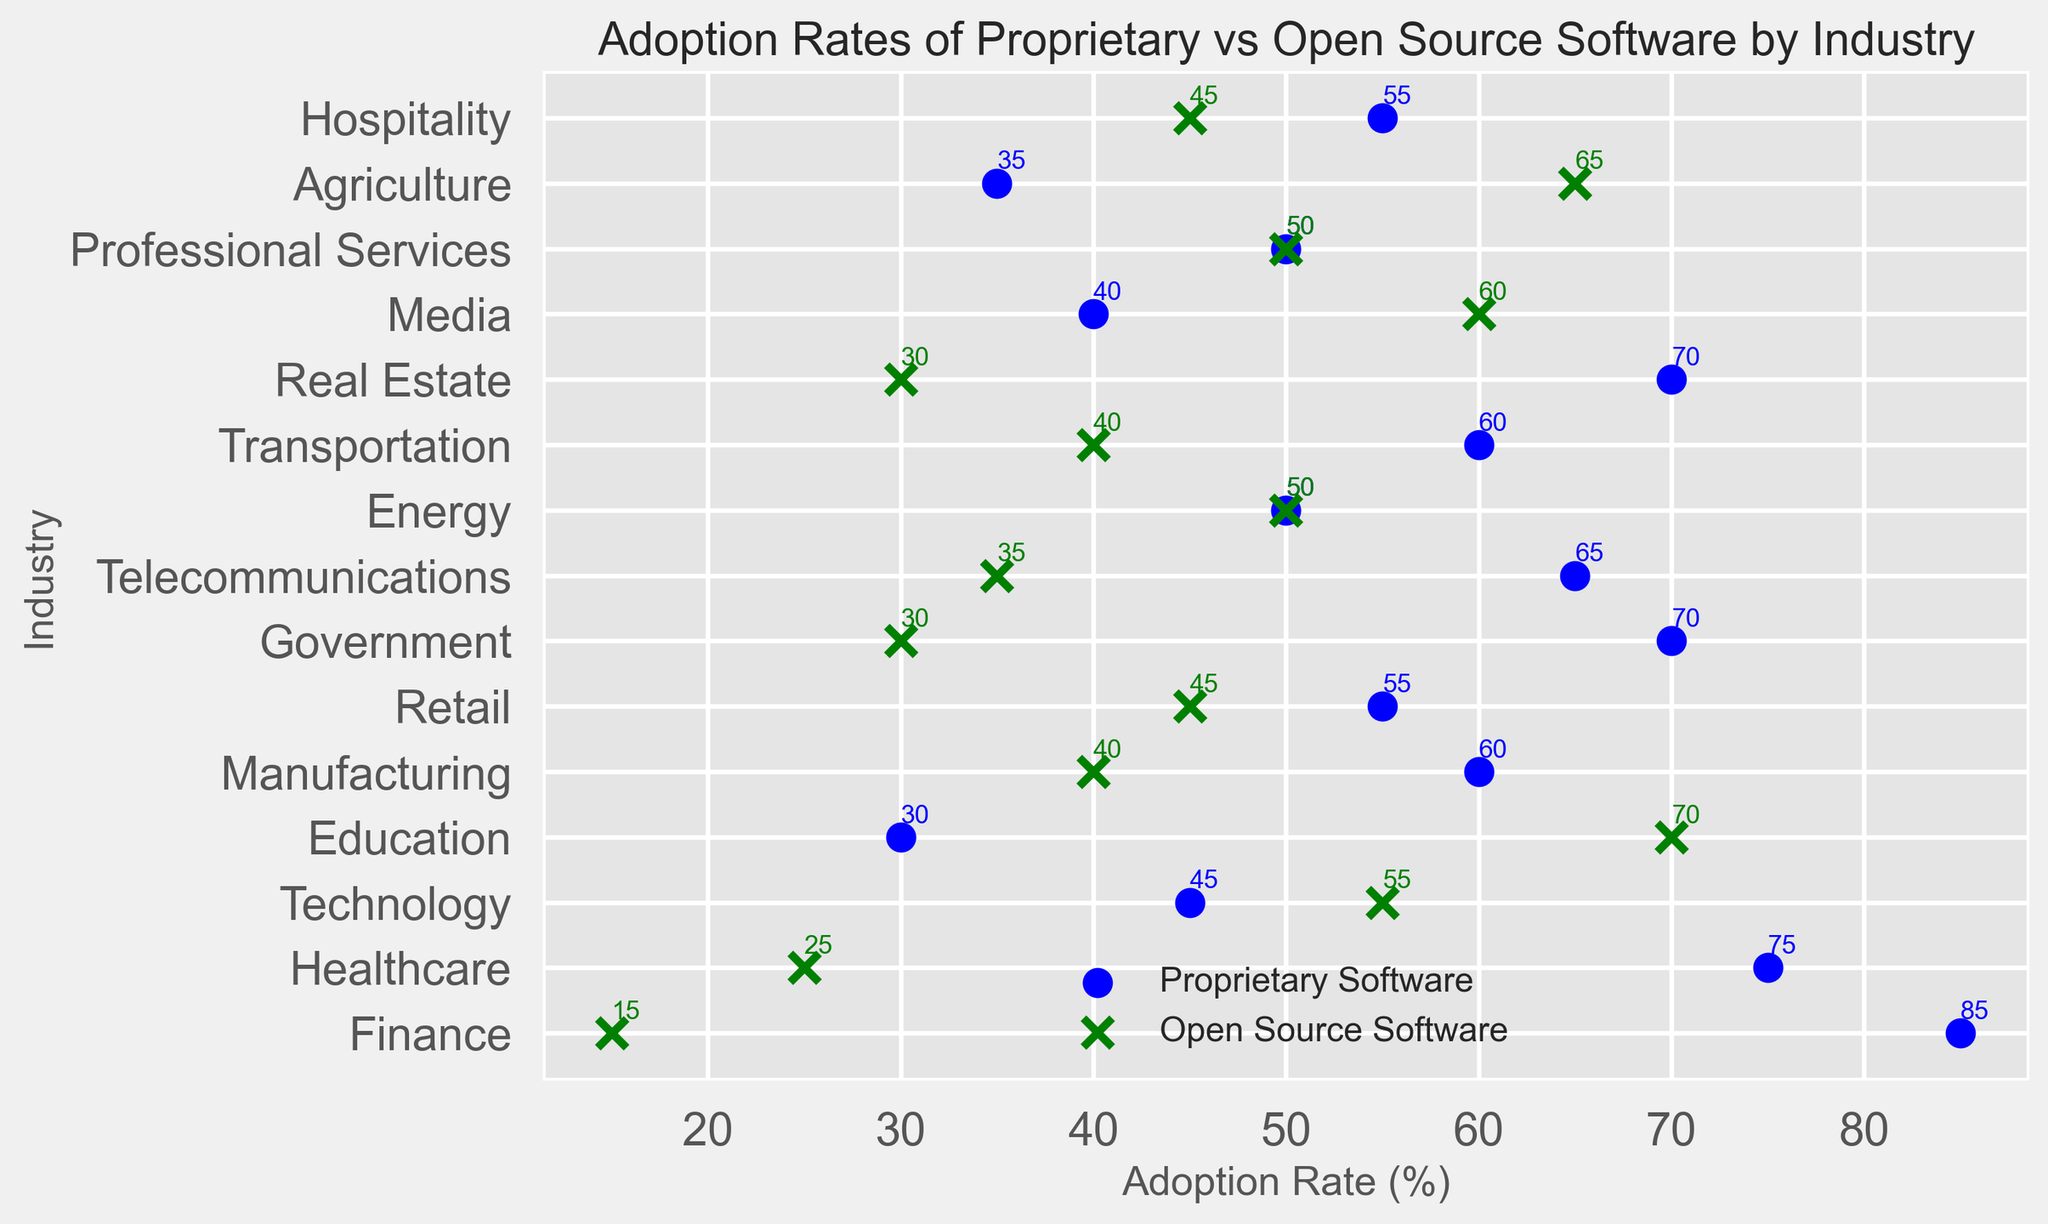What industry has the highest adoption rate for proprietary software? To find this, locate the marker on the scatter plot where the adoption rate for proprietary software is highest. The industry with the highest adoption rate for proprietary software is Finance with 85%.
Answer: Finance Which industry has a higher adoption rate for open source software: Technology or Healthcare? Compare the open source software adoption rates for Technology and Healthcare. Technology has an adoption rate of 55%, while Healthcare has a lower adoption rate of 25%. Thus, Technology has a higher adoption rate for open source software.
Answer: Technology Which industry shows equal adoption rates for both proprietary and open source software? Identify any markers where the adoption rates for proprietary and open source software are the same. Both Energy and Professional Services show equal adoption rates of 50% for both types of software.
Answer: Energy and Professional Services What is the difference in open source software adoption rates between Agriculture and Media? Subtract the open source software adoption rate of Agriculture from that of Media (65% - 60%). The difference is 5%.
Answer: 5% For Telecommunications, how much higher is the adoption rate for proprietary software compared to open source software? Subtract the open source software adoption rate from the proprietary software adoption rate for Telecommunications (65% - 35%). The difference is 30%.
Answer: 30% Which industry has a lower proprietary software adoption rate: Retail or Manufacturing? Compare the proprietary software adoption rates for Retail and Manufacturing. Retail has an adoption rate of 55%, while Manufacturing has a higher rate of 60%. Thus, Retail has a lower adoption rate.
Answer: Retail How does the adoption rate of open source software in Education compare to that in Hospitality? Compare the open source software adoption rates for Education and Hospitality. Education has a higher adoption rate of 70% compared to 45% for Hospitality.
Answer: Higher What is the sum of proprietary software adoption rates in Finance and Government? Add the proprietary software adoption rates for Finance and Government (85% + 70%). The sum is 155%.
Answer: 155% Which industry has the closest adoption rates between proprietary and open source software? Look for industries where the markers for both software types are closest to each other. Energy and Professional Services, both with equal rates of 50%, have the closest adoption rates between proprietary and open source software.
Answer: Energy and Professional Services What is the average open source software adoption rate for the Finance, Healthcare, and Technology industries? Calculate the average by summing the open source adoption rates for Finance, Healthcare, and Technology, then dividing by 3 ((15 + 25 + 55) / 3). The average adoption rate is 31.67%.
Answer: 31.67% 